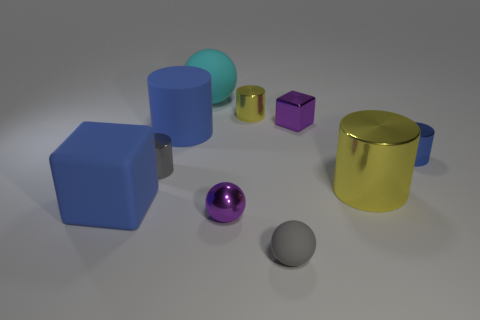Subtract all cyan cubes. How many blue cylinders are left? 2 Subtract 1 spheres. How many spheres are left? 2 Subtract all gray cylinders. How many cylinders are left? 4 Subtract all tiny purple shiny spheres. How many spheres are left? 2 Subtract all cyan cylinders. Subtract all green spheres. How many cylinders are left? 5 Subtract 0 red cylinders. How many objects are left? 10 Subtract all blocks. How many objects are left? 8 Subtract all small yellow metal cylinders. Subtract all yellow cylinders. How many objects are left? 7 Add 1 rubber things. How many rubber things are left? 5 Add 1 purple matte cubes. How many purple matte cubes exist? 1 